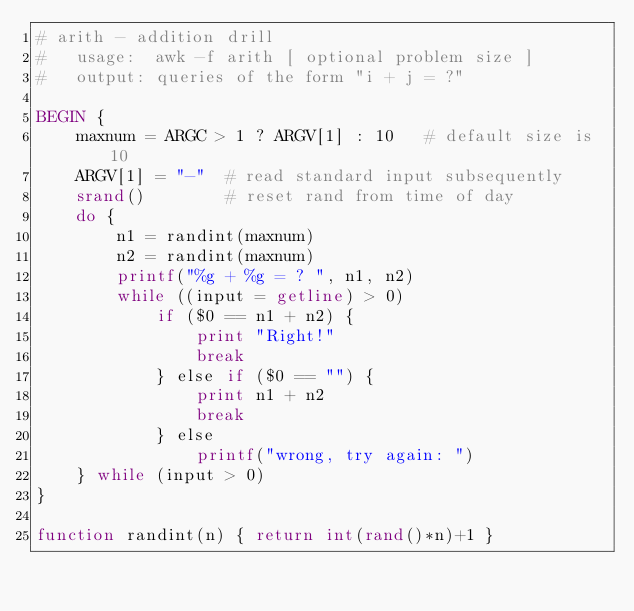Convert code to text. <code><loc_0><loc_0><loc_500><loc_500><_Awk_># arith - addition drill
#   usage:  awk -f arith [ optional problem size ]
#   output: queries of the form "i + j = ?"

BEGIN {
    maxnum = ARGC > 1 ? ARGV[1] : 10   # default size is 10
    ARGV[1] = "-"  # read standard input subsequently
    srand()        # reset rand from time of day
    do {
        n1 = randint(maxnum)
        n2 = randint(maxnum)
        printf("%g + %g = ? ", n1, n2)
        while ((input = getline) > 0)
            if ($0 == n1 + n2) {
                print "Right!"
                break
            } else if ($0 == "") {
                print n1 + n2
                break
            } else
                printf("wrong, try again: ")
    } while (input > 0)
}

function randint(n) { return int(rand()*n)+1 }
</code> 